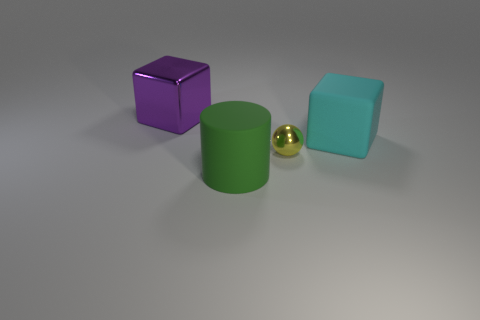There is a thing behind the block to the right of the cylinder; what is its material? The object you are referring to appears to be a small, shiny sphere behind the purple cube to the right of the green cylinder. Its reflective surface and color suggest it is made of a polished metal, possibly brass or gold-plated metal, given its golden hue. 